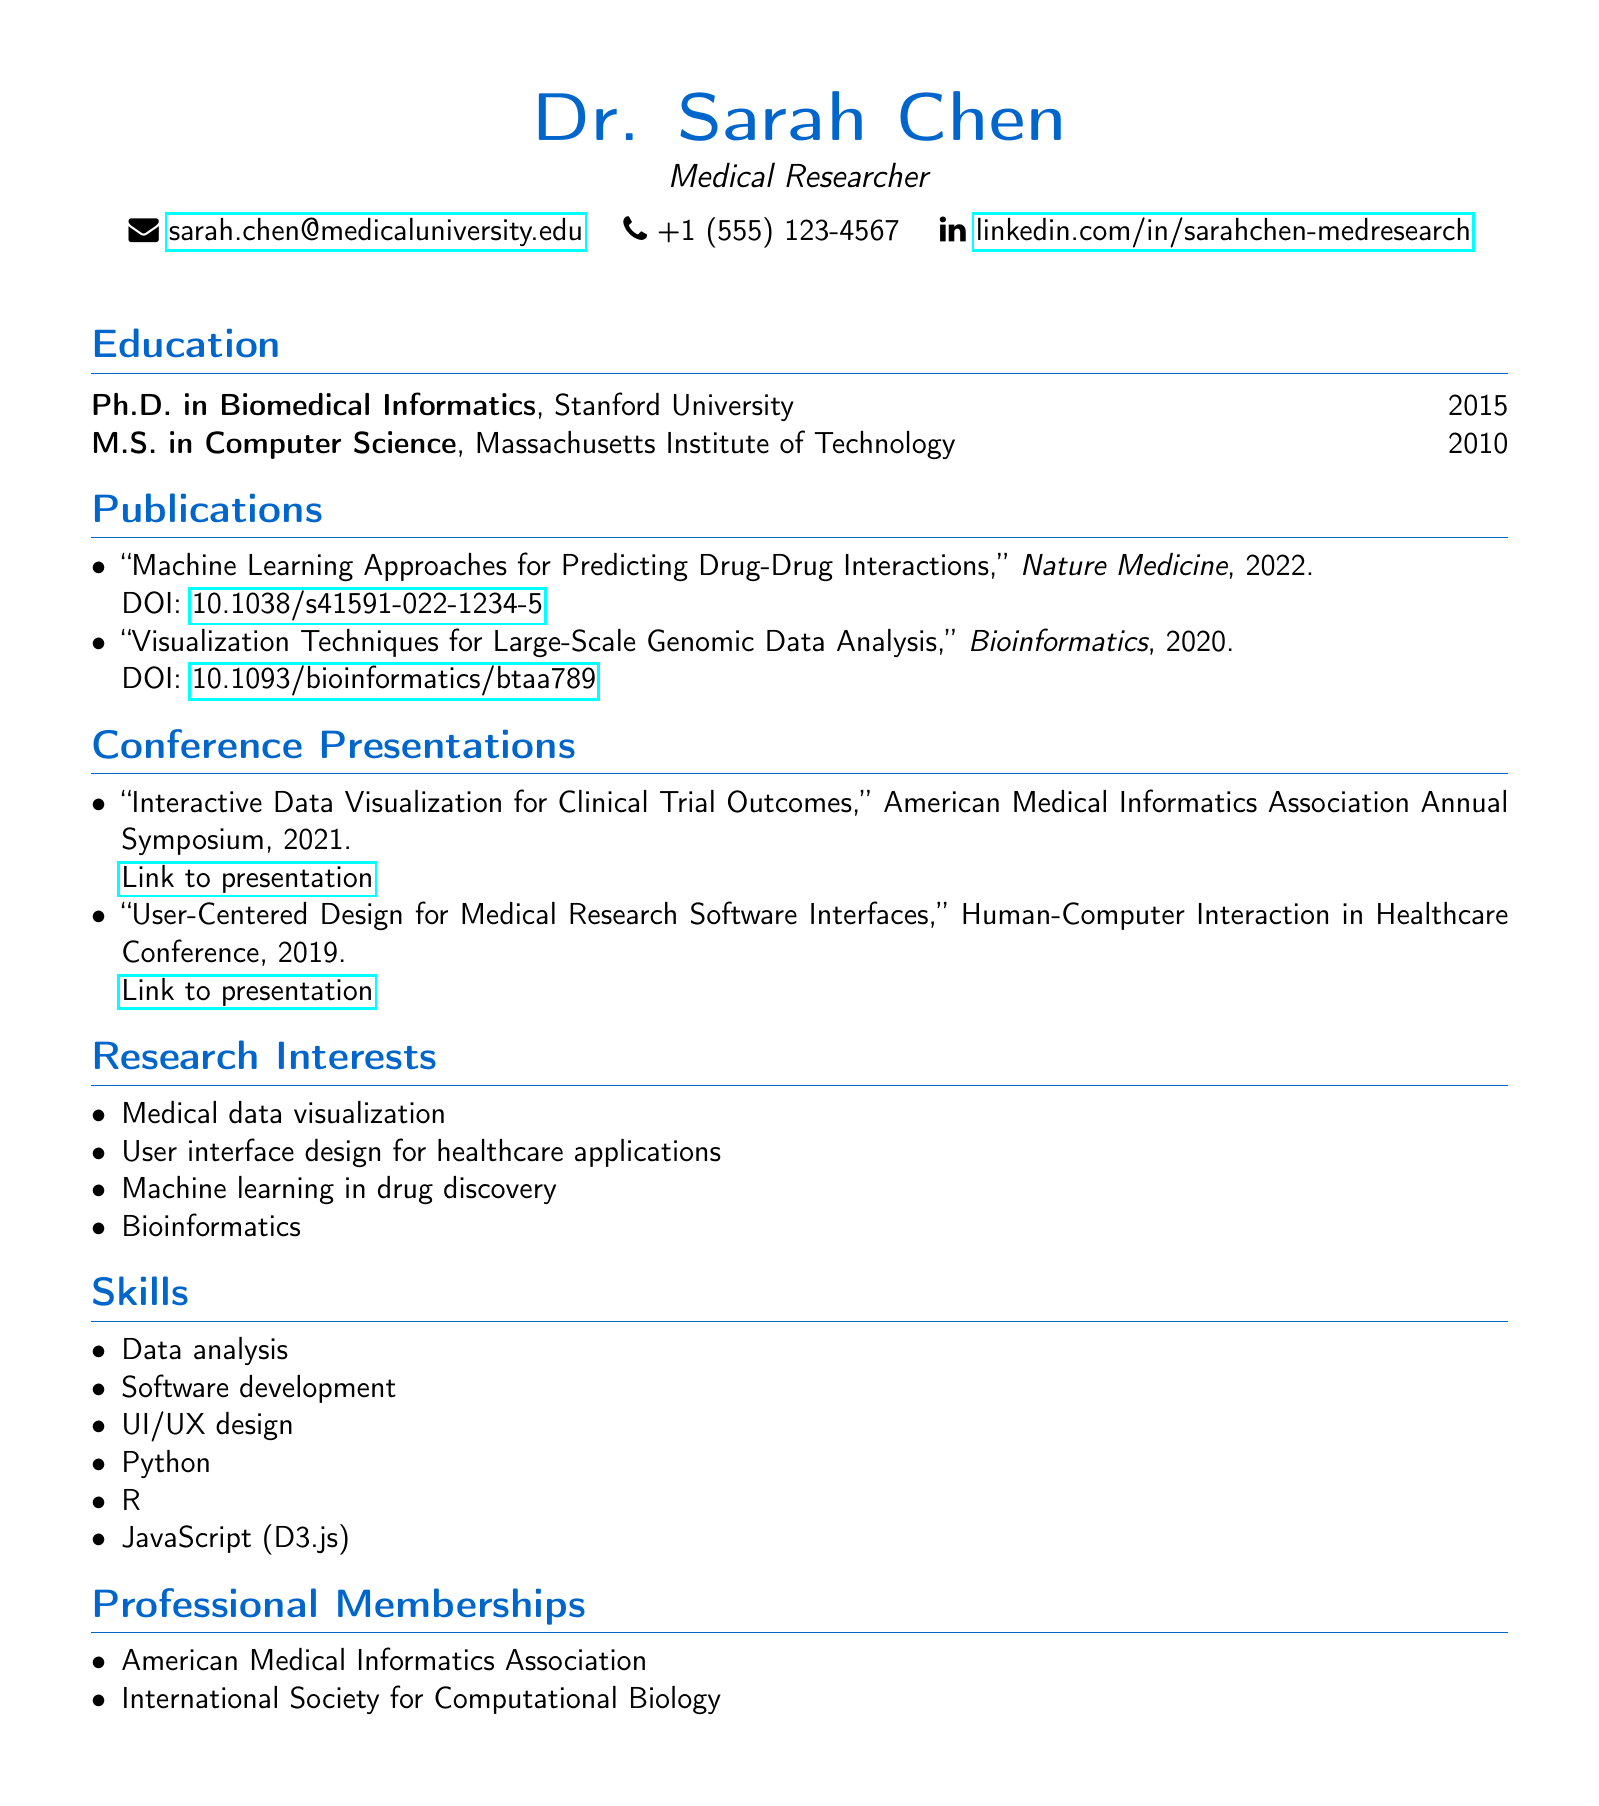What is Dr. Sarah Chen's email address? The email address of Dr. Sarah Chen is clearly stated in the personal information section.
Answer: sarah.chen@medicaluniversity.edu What degree did Dr. Sarah Chen obtain in 2015? This degree is specified in the education section under the year 2015.
Answer: Ph.D. in Biomedical Informatics Which journal published the 2022 publication? The journal name for the respective publication is mentioned in the publications section.
Answer: Nature Medicine How many conference presentations are listed in the CV? The number of conference presentations can be counted in the conference presentations section.
Answer: 2 What are Dr. Sarah Chen's skills related to programming? Skills related to programming are explicitly listed in the skills section of the document.
Answer: Python, R, JavaScript (D3.js) What is the title of the 2021 conference presentation? The title of this presentation can be found in the conference presentations section under the year 2021.
Answer: Interactive Data Visualization for Clinical Trial Outcomes What is Dr. Sarah Chen's research interest related to healthcare applications? This specific research interest is mentioned in the research interests section under a clear category.
Answer: User interface design for healthcare applications Which professional organization is Dr. Sarah Chen a member of? The memberships are clearly listed in the professional memberships section.
Answer: American Medical Informatics Association What year was the M.S. in Computer Science obtained? This information is contained in the education section alongside the corresponding institution.
Answer: 2010 